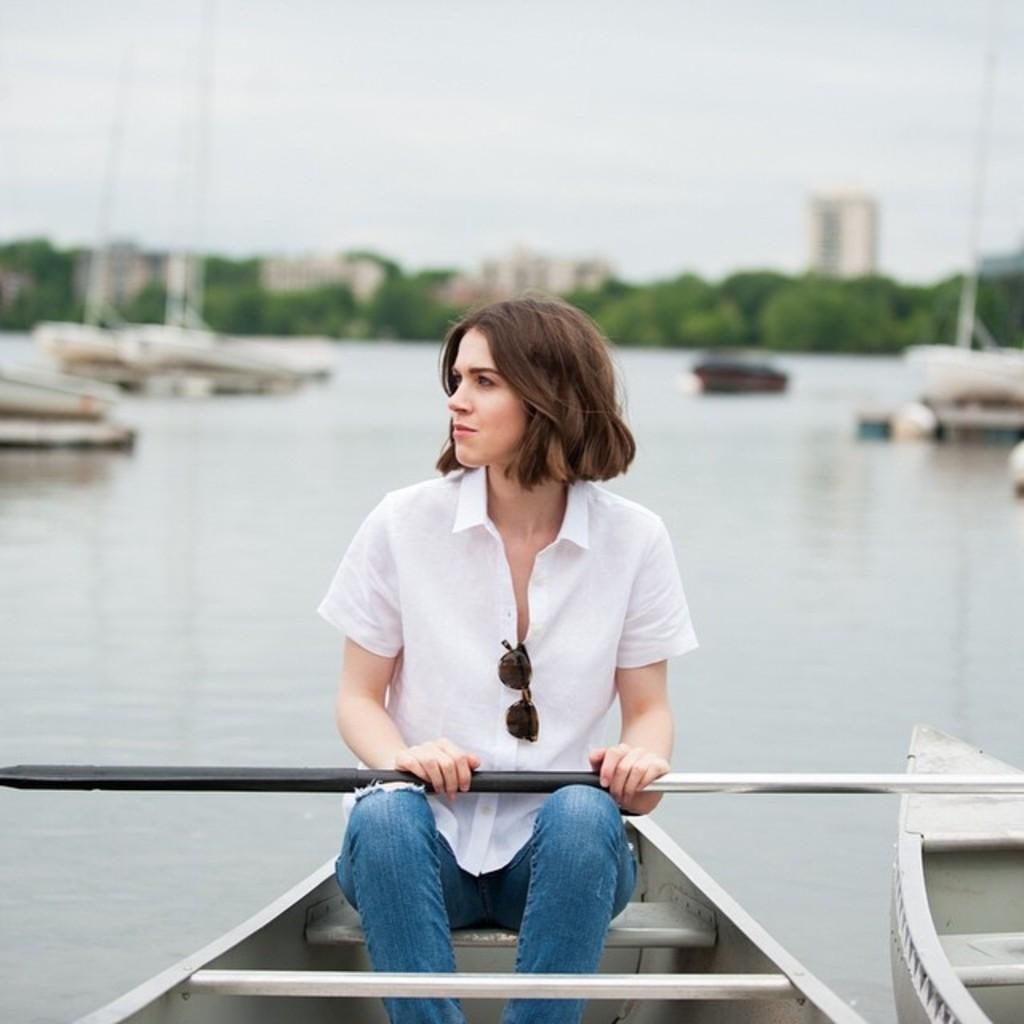What is the lady in the image doing? The lady is sitting on a boat in the image. What is the lady holding in her hand? The lady is holding a road in her hand. What can be seen in the background of the image? There are boats, trees, and buildings in the background of the image. How is the background of the image depicted? The background is blurred. What type of soup is being served in the image? There is no soup present in the image; it features a lady sitting on a boat holding a road. What kind of insurance policy is being discussed in the image? There is no discussion of insurance in the image; it focuses on a lady sitting on a boat holding a road. 